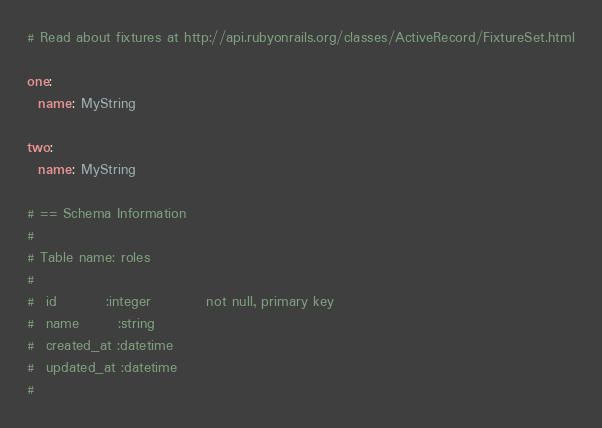<code> <loc_0><loc_0><loc_500><loc_500><_YAML_># Read about fixtures at http://api.rubyonrails.org/classes/ActiveRecord/FixtureSet.html

one:
  name: MyString

two:
  name: MyString

# == Schema Information
#
# Table name: roles
#
#  id         :integer          not null, primary key
#  name       :string
#  created_at :datetime
#  updated_at :datetime
#
</code> 